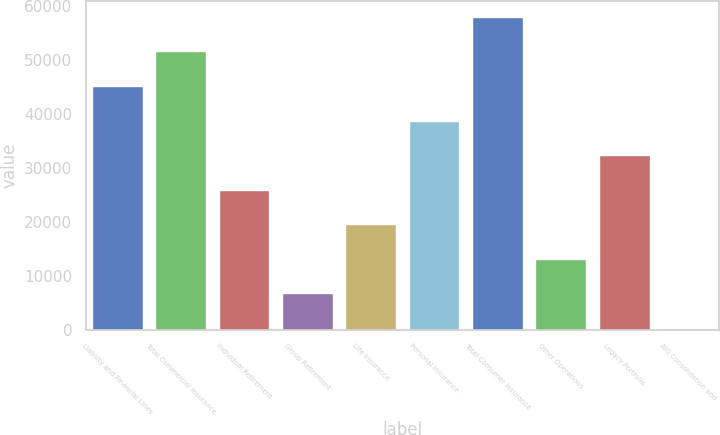Convert chart to OTSL. <chart><loc_0><loc_0><loc_500><loc_500><bar_chart><fcel>Liability and Financial Lines<fcel>Total Commercial Insurance<fcel>Individual Retirement<fcel>Group Retirement<fcel>Life Insurance<fcel>Personal Insurance<fcel>Total Consumer Insurance<fcel>Other Operations<fcel>Legacy Portfolio<fcel>AIG Consolidation and<nl><fcel>45181.1<fcel>51589.4<fcel>25956.2<fcel>6731.3<fcel>19547.9<fcel>38772.8<fcel>57997.7<fcel>13139.6<fcel>32364.5<fcel>323<nl></chart> 